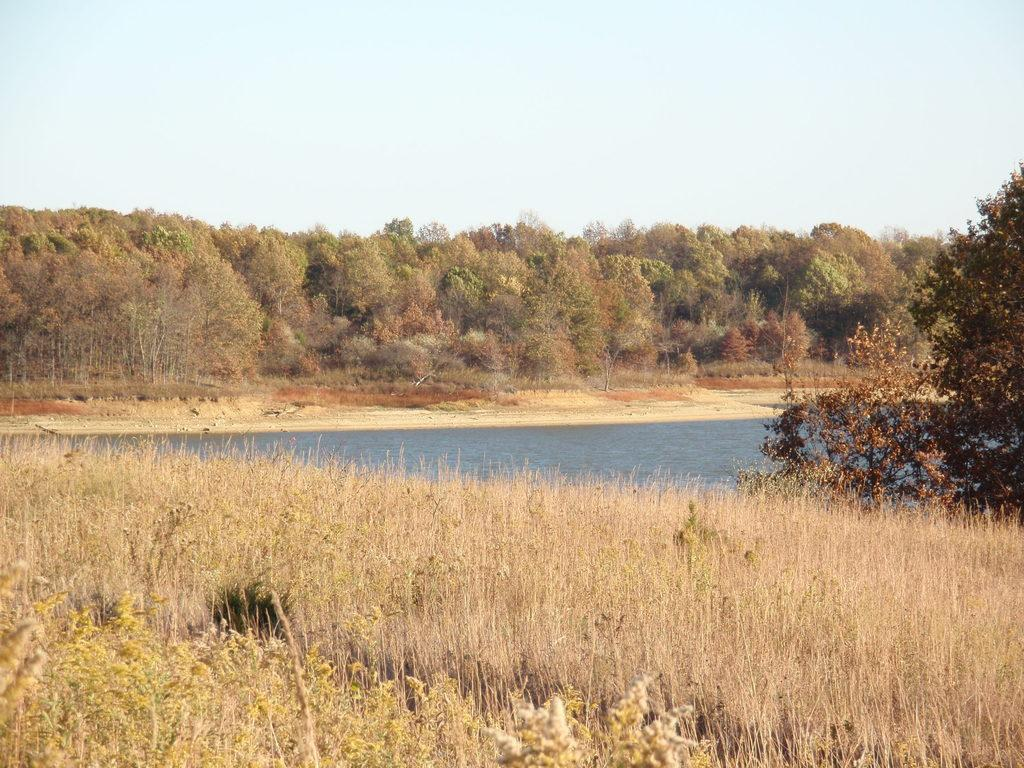What type of vegetation is present on the land in the image? There are plants on the land in the image. What body of water is visible in the image? There is a lake in the middle of the image. What can be seen in the background of the image? There are trees and the sky visible in the background of the image. What flavor: What flavor of curtain can be seen hanging near the lake in the image? There are no curtains present in the image, and therefore no flavor can be associated with them. 